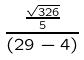Convert formula to latex. <formula><loc_0><loc_0><loc_500><loc_500>\frac { \frac { \sqrt { 3 2 6 } } { 5 } } { ( 2 9 - 4 ) }</formula> 